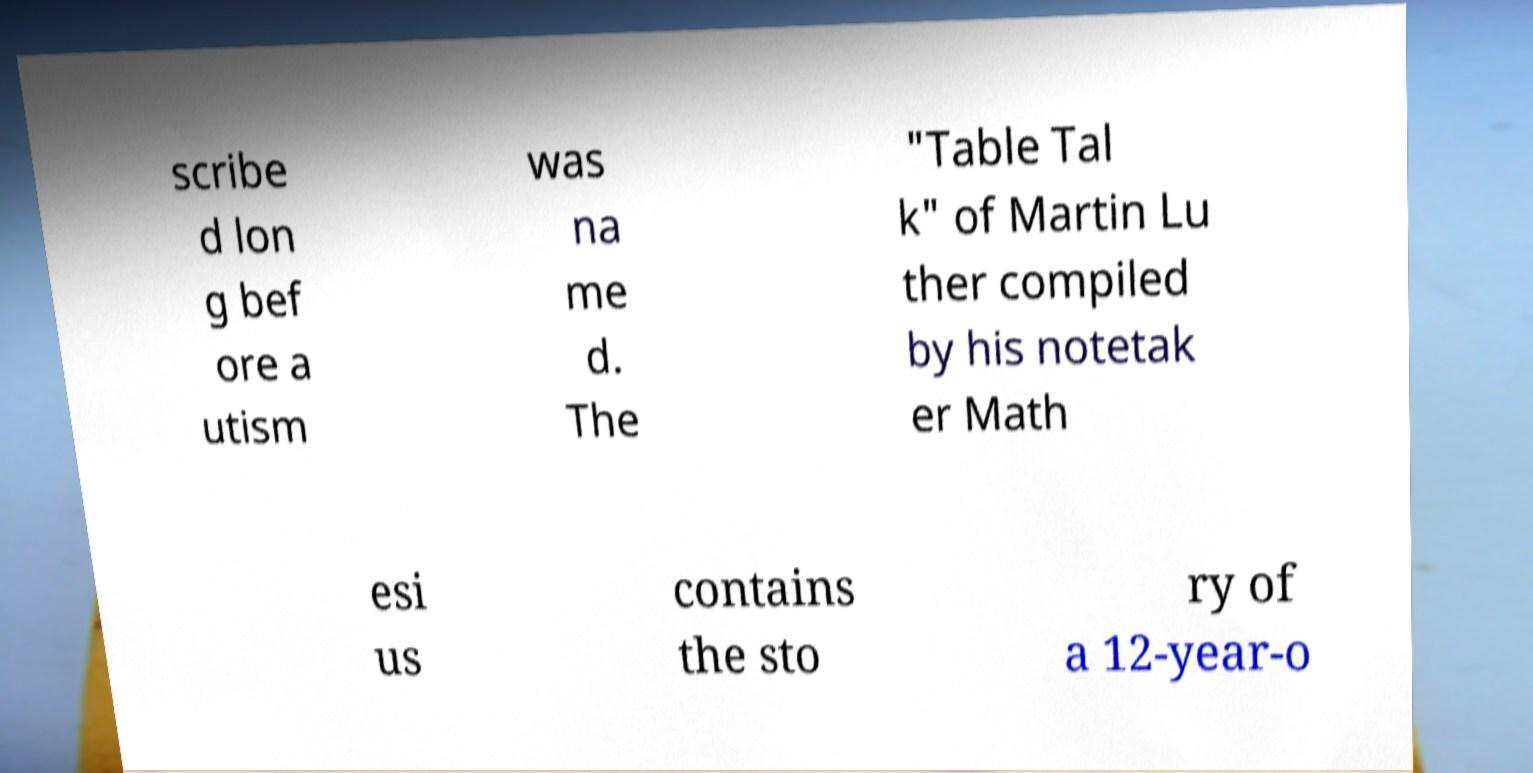Could you extract and type out the text from this image? scribe d lon g bef ore a utism was na me d. The "Table Tal k" of Martin Lu ther compiled by his notetak er Math esi us contains the sto ry of a 12-year-o 